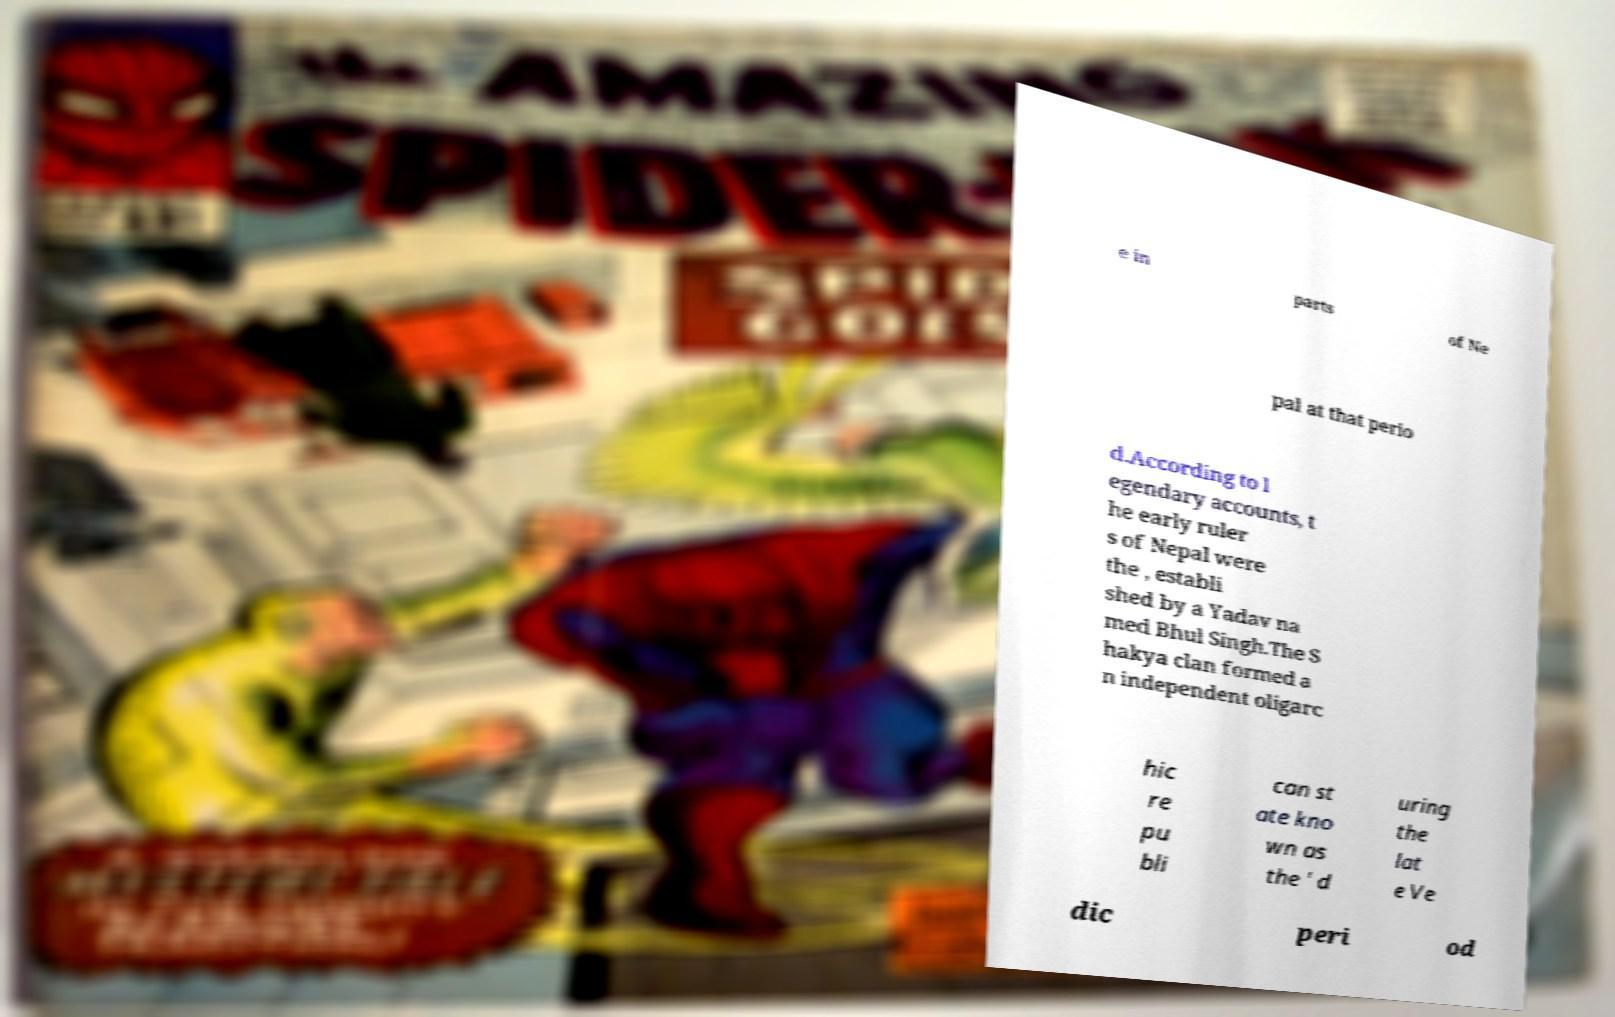Could you extract and type out the text from this image? e in parts of Ne pal at that perio d.According to l egendary accounts, t he early ruler s of Nepal were the , establi shed by a Yadav na med Bhul Singh.The S hakya clan formed a n independent oligarc hic re pu bli can st ate kno wn as the ' d uring the lat e Ve dic peri od 